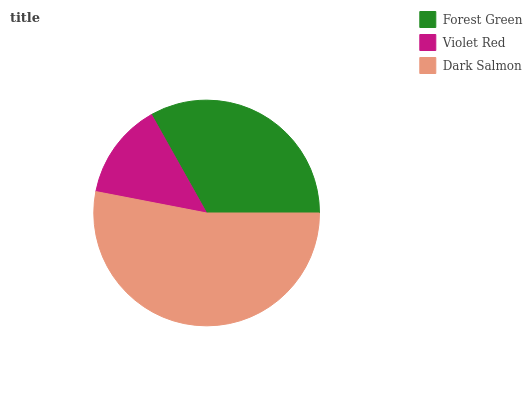Is Violet Red the minimum?
Answer yes or no. Yes. Is Dark Salmon the maximum?
Answer yes or no. Yes. Is Dark Salmon the minimum?
Answer yes or no. No. Is Violet Red the maximum?
Answer yes or no. No. Is Dark Salmon greater than Violet Red?
Answer yes or no. Yes. Is Violet Red less than Dark Salmon?
Answer yes or no. Yes. Is Violet Red greater than Dark Salmon?
Answer yes or no. No. Is Dark Salmon less than Violet Red?
Answer yes or no. No. Is Forest Green the high median?
Answer yes or no. Yes. Is Forest Green the low median?
Answer yes or no. Yes. Is Dark Salmon the high median?
Answer yes or no. No. Is Violet Red the low median?
Answer yes or no. No. 